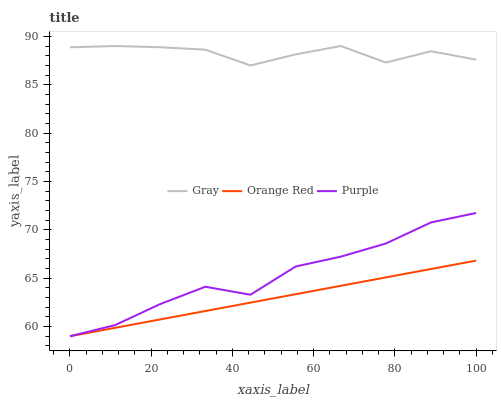Does Orange Red have the minimum area under the curve?
Answer yes or no. Yes. Does Gray have the maximum area under the curve?
Answer yes or no. Yes. Does Gray have the minimum area under the curve?
Answer yes or no. No. Does Orange Red have the maximum area under the curve?
Answer yes or no. No. Is Orange Red the smoothest?
Answer yes or no. Yes. Is Gray the roughest?
Answer yes or no. Yes. Is Gray the smoothest?
Answer yes or no. No. Is Orange Red the roughest?
Answer yes or no. No. Does Gray have the lowest value?
Answer yes or no. No. Does Gray have the highest value?
Answer yes or no. Yes. Does Orange Red have the highest value?
Answer yes or no. No. Is Orange Red less than Gray?
Answer yes or no. Yes. Is Gray greater than Orange Red?
Answer yes or no. Yes. Does Purple intersect Orange Red?
Answer yes or no. Yes. Is Purple less than Orange Red?
Answer yes or no. No. Is Purple greater than Orange Red?
Answer yes or no. No. Does Orange Red intersect Gray?
Answer yes or no. No. 